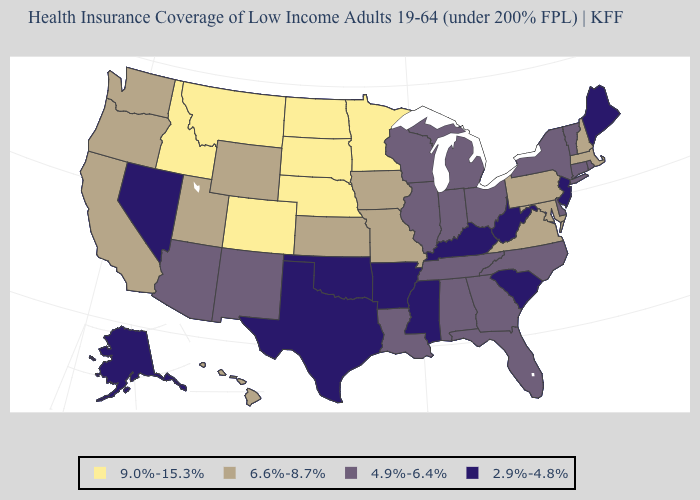What is the value of Washington?
Keep it brief. 6.6%-8.7%. Name the states that have a value in the range 2.9%-4.8%?
Concise answer only. Alaska, Arkansas, Kentucky, Maine, Mississippi, Nevada, New Jersey, Oklahoma, South Carolina, Texas, West Virginia. What is the value of Idaho?
Write a very short answer. 9.0%-15.3%. Among the states that border Massachusetts , does New York have the highest value?
Quick response, please. No. Which states have the highest value in the USA?
Quick response, please. Colorado, Idaho, Minnesota, Montana, Nebraska, North Dakota, South Dakota. Among the states that border Wisconsin , which have the lowest value?
Concise answer only. Illinois, Michigan. Does South Dakota have the highest value in the USA?
Keep it brief. Yes. What is the highest value in the USA?
Concise answer only. 9.0%-15.3%. What is the value of Georgia?
Answer briefly. 4.9%-6.4%. Does Nevada have the lowest value in the West?
Quick response, please. Yes. Among the states that border Missouri , which have the highest value?
Concise answer only. Nebraska. What is the value of Kentucky?
Quick response, please. 2.9%-4.8%. What is the value of Missouri?
Quick response, please. 6.6%-8.7%. Name the states that have a value in the range 2.9%-4.8%?
Concise answer only. Alaska, Arkansas, Kentucky, Maine, Mississippi, Nevada, New Jersey, Oklahoma, South Carolina, Texas, West Virginia. Does Illinois have the highest value in the USA?
Be succinct. No. 